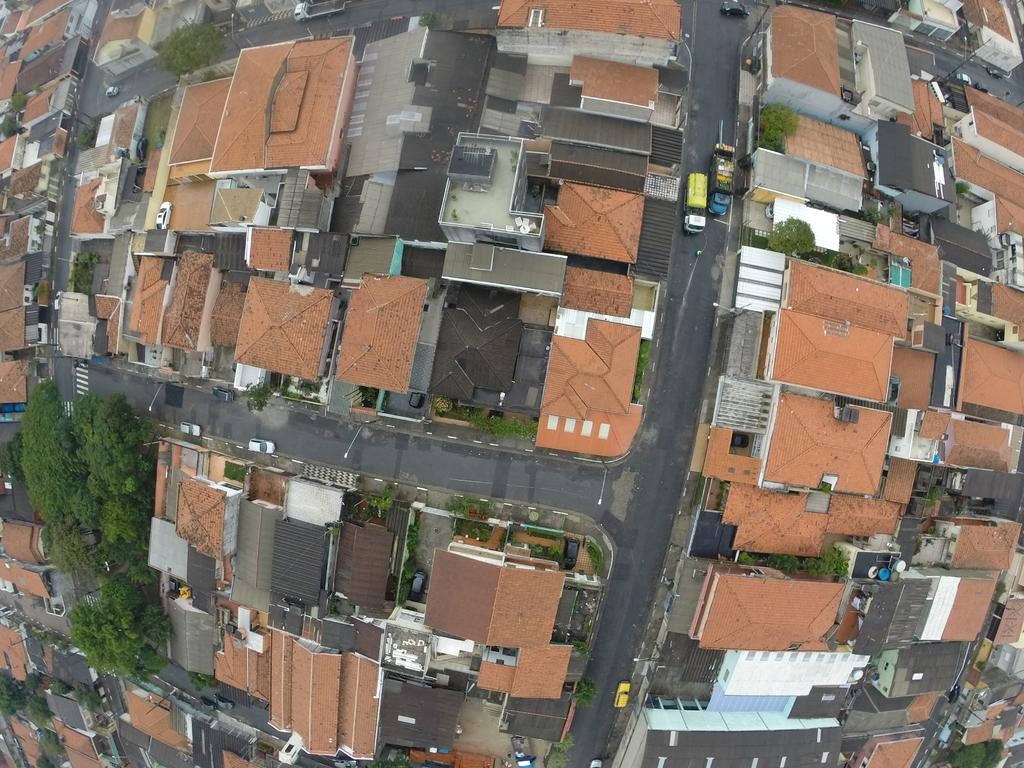What type of structures can be seen in the image? There are buildings in the image. What other natural elements are present in the image? There are trees in the image. What type of transportation infrastructure is visible in the image? There are roads in the image. What type of objects can be seen moving along the roads? There are vehicles in the image. Where is the glove located in the image? There is no glove present in the image. What type of musical instrument is being played by the trees in the image? There are no musical instruments being played by the trees in the image. 